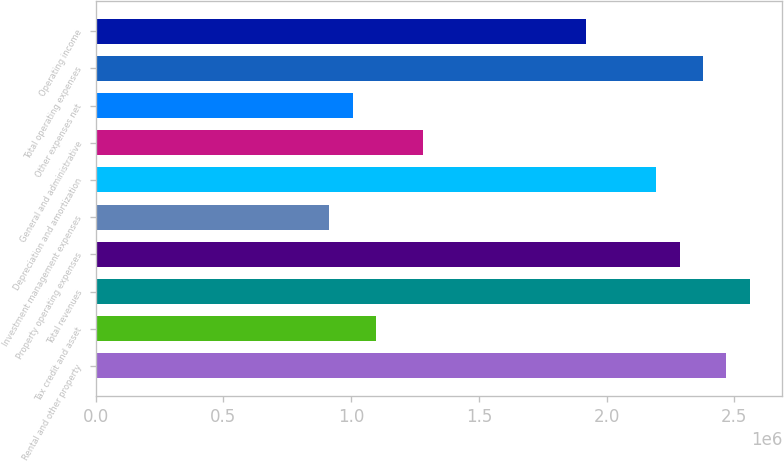Convert chart. <chart><loc_0><loc_0><loc_500><loc_500><bar_chart><fcel>Rental and other property<fcel>Tax credit and asset<fcel>Total revenues<fcel>Property operating expenses<fcel>Investment management expenses<fcel>Depreciation and amortization<fcel>General and administrative<fcel>Other expenses net<fcel>Total operating expenses<fcel>Operating income<nl><fcel>2.46876e+06<fcel>1.09723e+06<fcel>2.56019e+06<fcel>2.28589e+06<fcel>914355<fcel>2.19445e+06<fcel>1.2801e+06<fcel>1.00579e+06<fcel>2.37732e+06<fcel>1.92015e+06<nl></chart> 